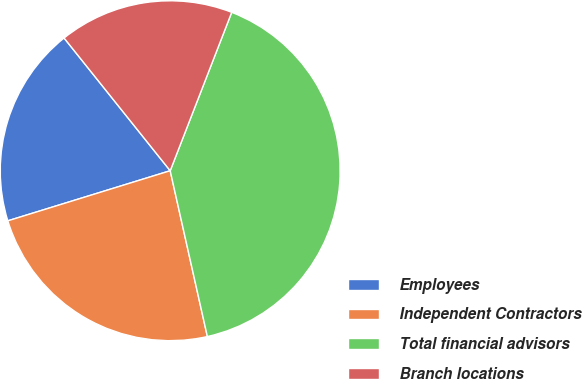Convert chart to OTSL. <chart><loc_0><loc_0><loc_500><loc_500><pie_chart><fcel>Employees<fcel>Independent Contractors<fcel>Total financial advisors<fcel>Branch locations<nl><fcel>19.03%<fcel>23.75%<fcel>40.6%<fcel>16.63%<nl></chart> 